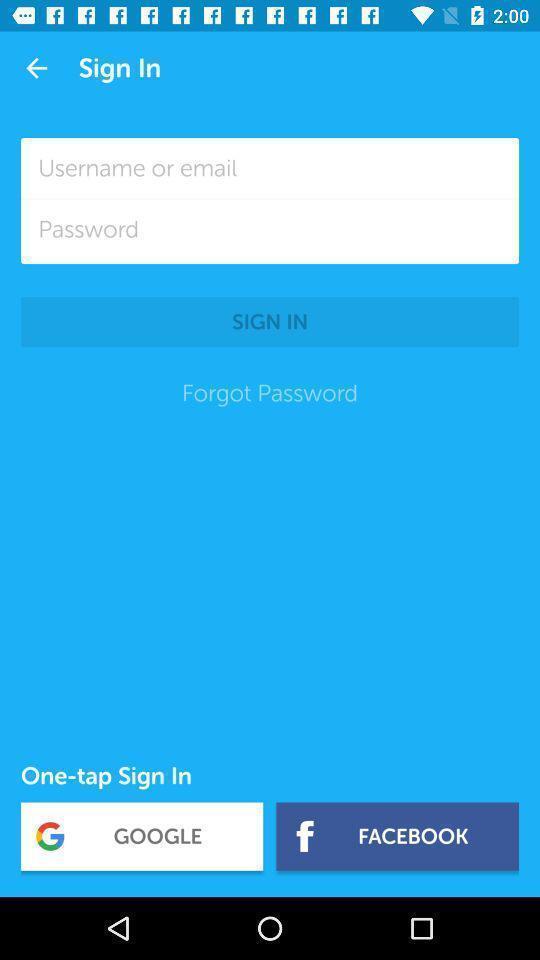What is the overall content of this screenshot? Sign in page to get the access from application. 